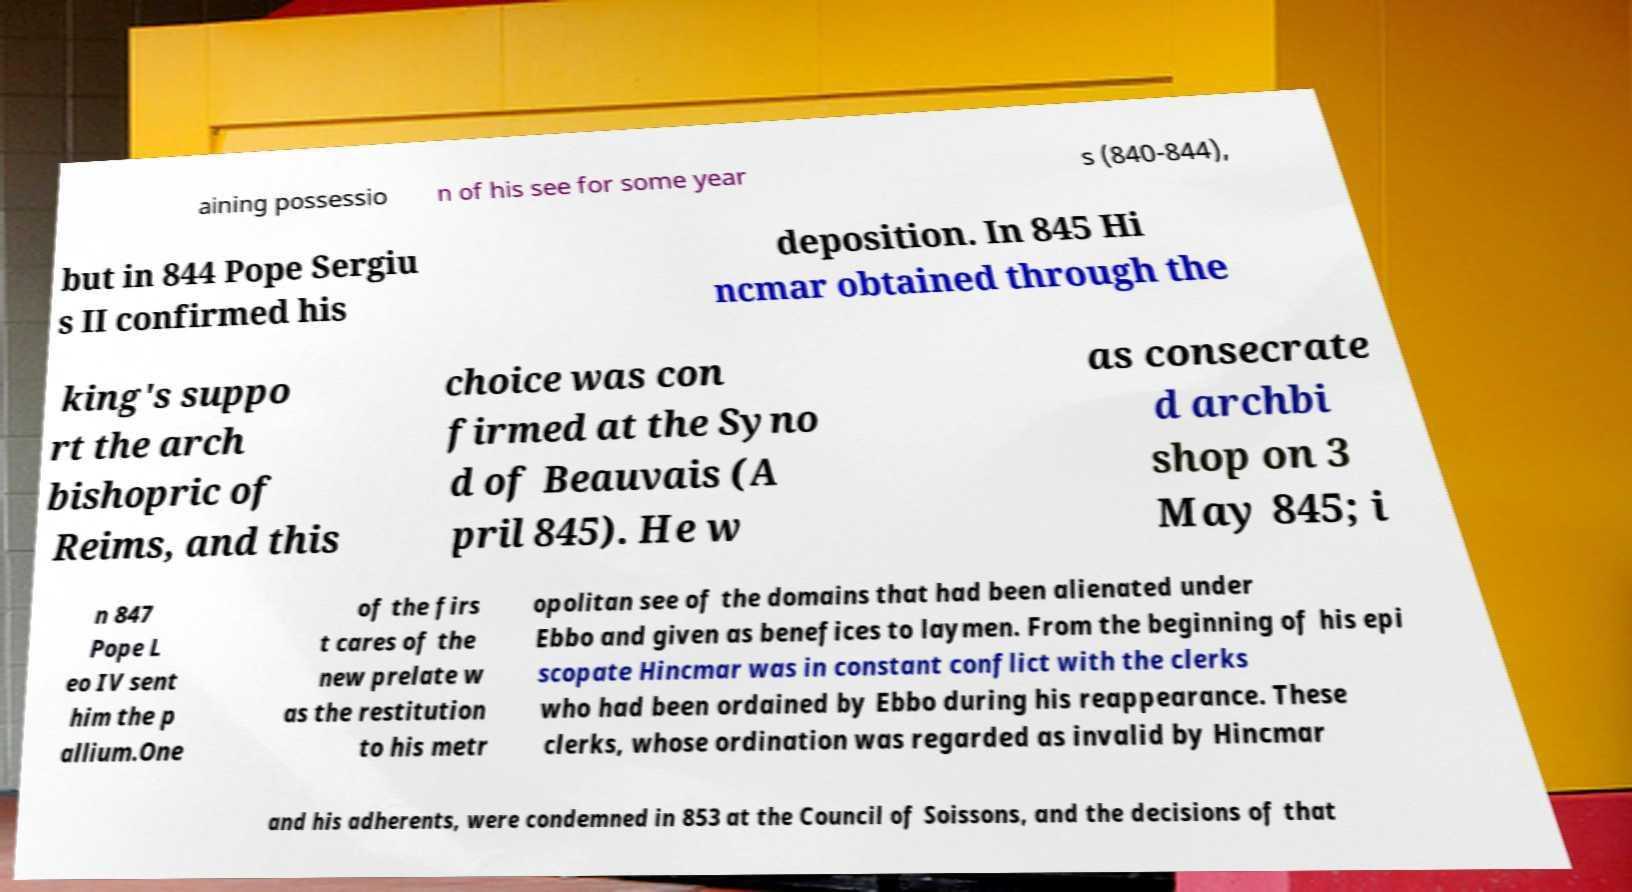Can you read and provide the text displayed in the image?This photo seems to have some interesting text. Can you extract and type it out for me? aining possessio n of his see for some year s (840-844), but in 844 Pope Sergiu s II confirmed his deposition. In 845 Hi ncmar obtained through the king's suppo rt the arch bishopric of Reims, and this choice was con firmed at the Syno d of Beauvais (A pril 845). He w as consecrate d archbi shop on 3 May 845; i n 847 Pope L eo IV sent him the p allium.One of the firs t cares of the new prelate w as the restitution to his metr opolitan see of the domains that had been alienated under Ebbo and given as benefices to laymen. From the beginning of his epi scopate Hincmar was in constant conflict with the clerks who had been ordained by Ebbo during his reappearance. These clerks, whose ordination was regarded as invalid by Hincmar and his adherents, were condemned in 853 at the Council of Soissons, and the decisions of that 